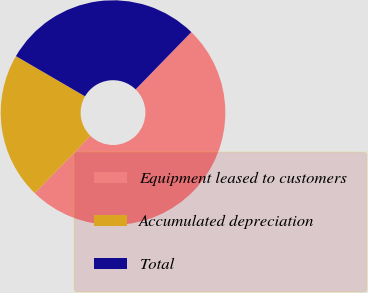<chart> <loc_0><loc_0><loc_500><loc_500><pie_chart><fcel>Equipment leased to customers<fcel>Accumulated depreciation<fcel>Total<nl><fcel>50.0%<fcel>21.11%<fcel>28.89%<nl></chart> 